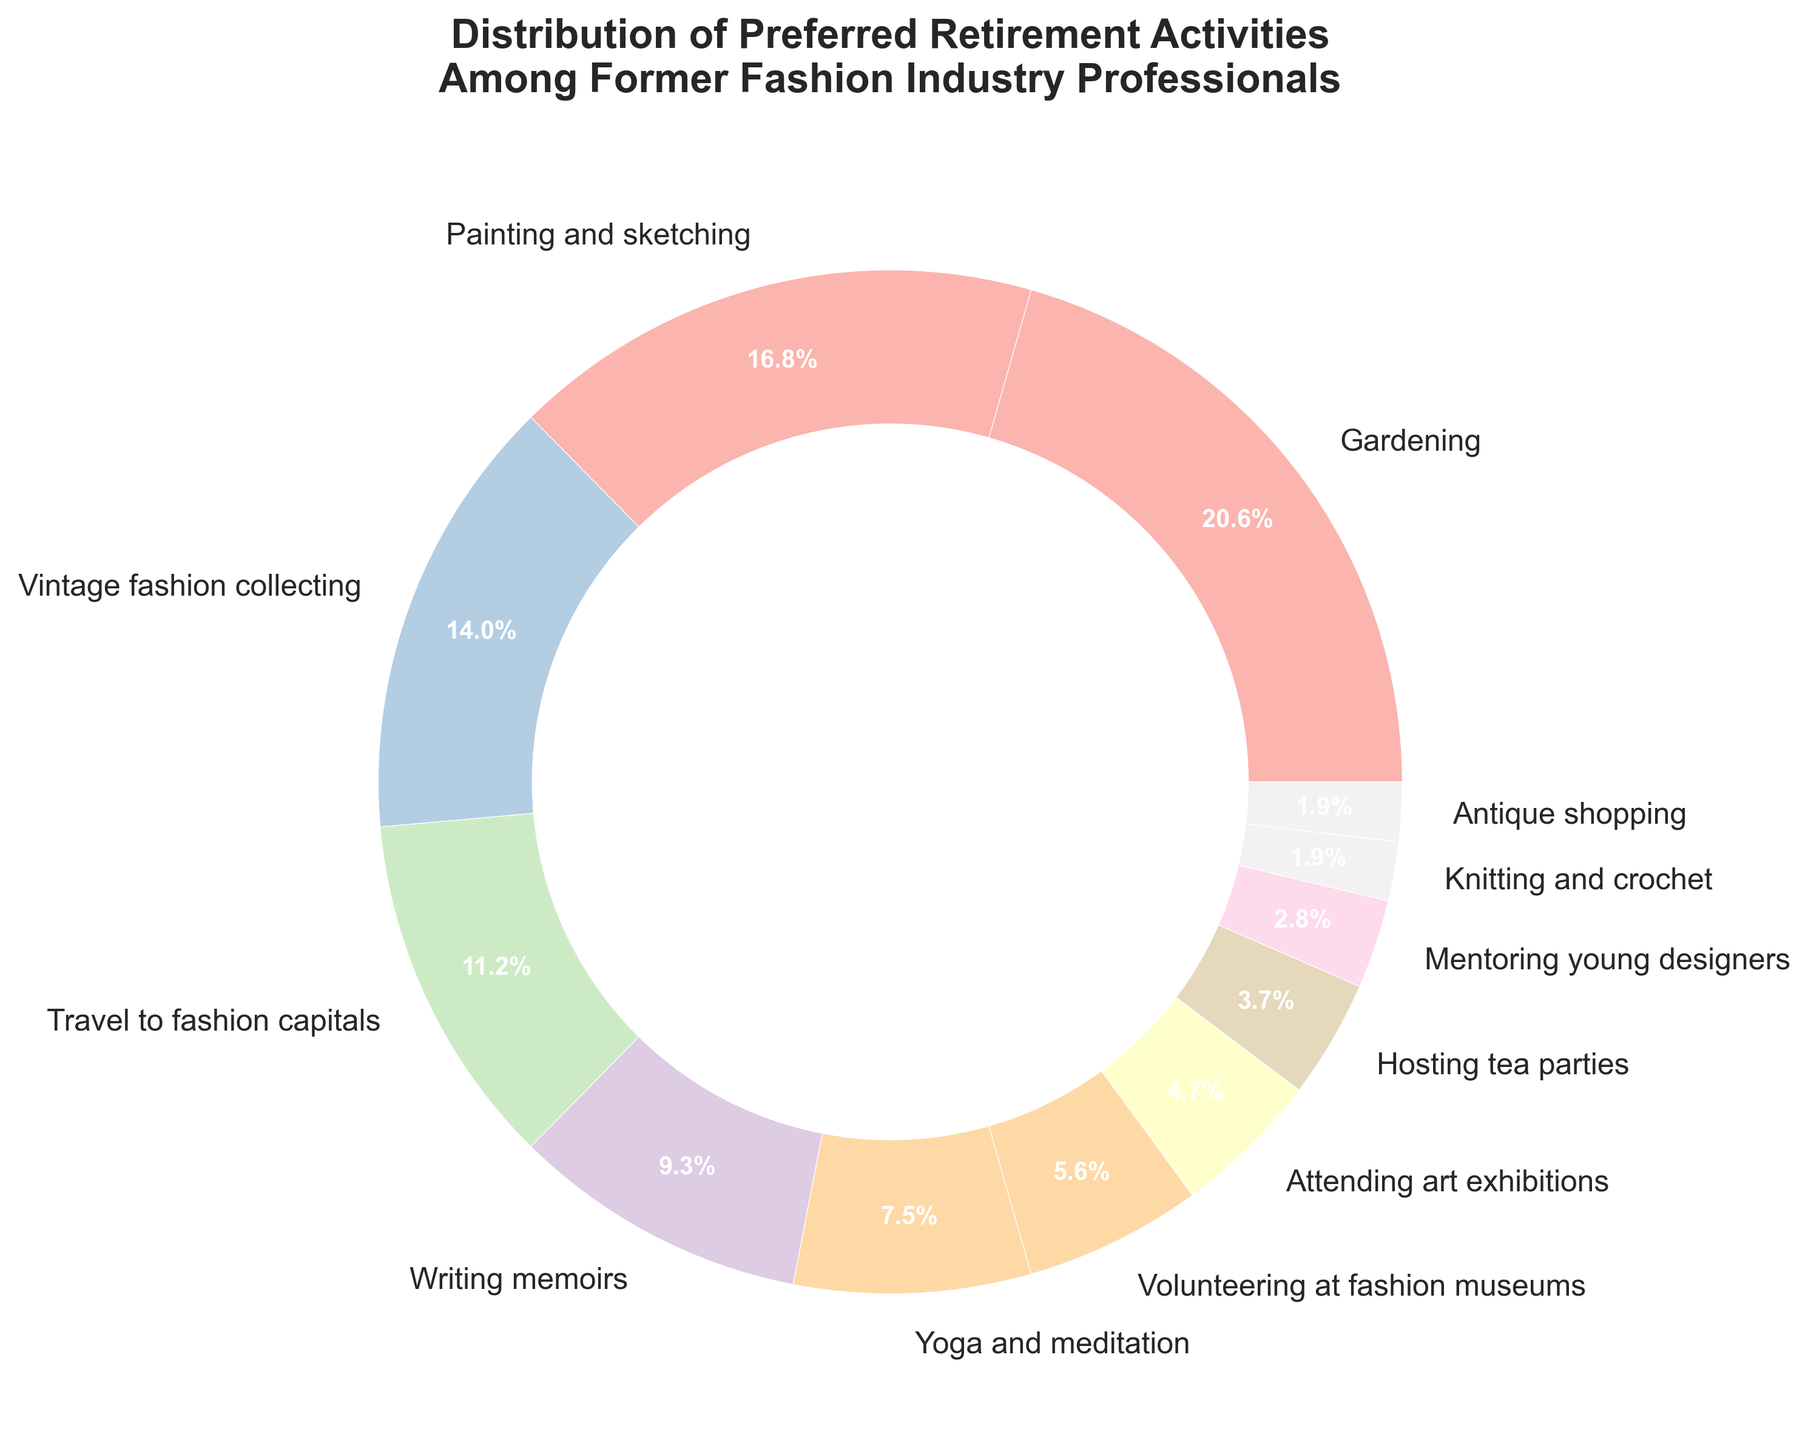Which activity is the most popular among retired fashion industry professionals? Identify the activity with the highest percentage in the pie chart.
Answer: Gardening How many activities have a popularity less than or equal to 5%? Count the slices in the pie chart with percentages less than or equal to 5%. Activities: Attending art exhibitions (5%), Hosting tea parties (4%), Mentoring young designers (3%), Knitting and crochet (2%), Antique shopping (2%) gives 5 activities.
Answer: 5 Which is more popular: Painting and sketching or Traveling to fashion capitals? Compare the percentages of the slices labeled "Painting and sketching" and "Travel to fashion capitals". Painting and sketching has 18% and Travel to fashion capitals has 12%.
Answer: Painting and sketching What is the total percentage of activities related to creative arts like painting, vintage fashion collecting, and writing memoirs? Add the percentages of Painting and sketching (18%), Vintage fashion collecting (15%), and Writing memoirs (10%).
Answer: 43% What percentage of former fashion industry professionals prefer activities that involve travel or interacting with the industry? Add percentages for Travel to fashion capitals (12%), Volunteering at fashion museums (6%), and Mentoring young designers (3%).
Answer: 21% Which activity is represented by the smallest slice in the pie chart? Identify the activity with the smallest percentage in the pie chart.
Answer: Knitting and crochet & Antique shopping Is the percentage of Gardening higher than the sum of Yoga and meditation, and Hosting tea parties? Compare 22% (Gardening) with the sum of 8% (Yoga and meditation) and 4% (Hosting tea parties). 22% > 12%.
Answer: Yes What is the difference in percentage between the most and least popular activities? Subtract the percentage of the least popular activities (2%) from the most popular activity (22%).
Answer: 20% Which has a higher percentage: Volunteering at fashion museums or Attending art exhibitions and how much more? Compare 6% (Volunteering at fashion museums) with 5% (Attending art exhibitions) and find the difference.
Answer: Volunteering at fashion museums, 1% more If you combine the percentages of Yoga and meditation, and Knitting and crochet, is it greater than the percentage for Painting and sketching? Sum the percentages for Yoga and meditation (8%) and Knitting and crochet (2%) then compare with Painting and sketching (18%). 8% + 2% = 10%; 10% < 18%.
Answer: No 